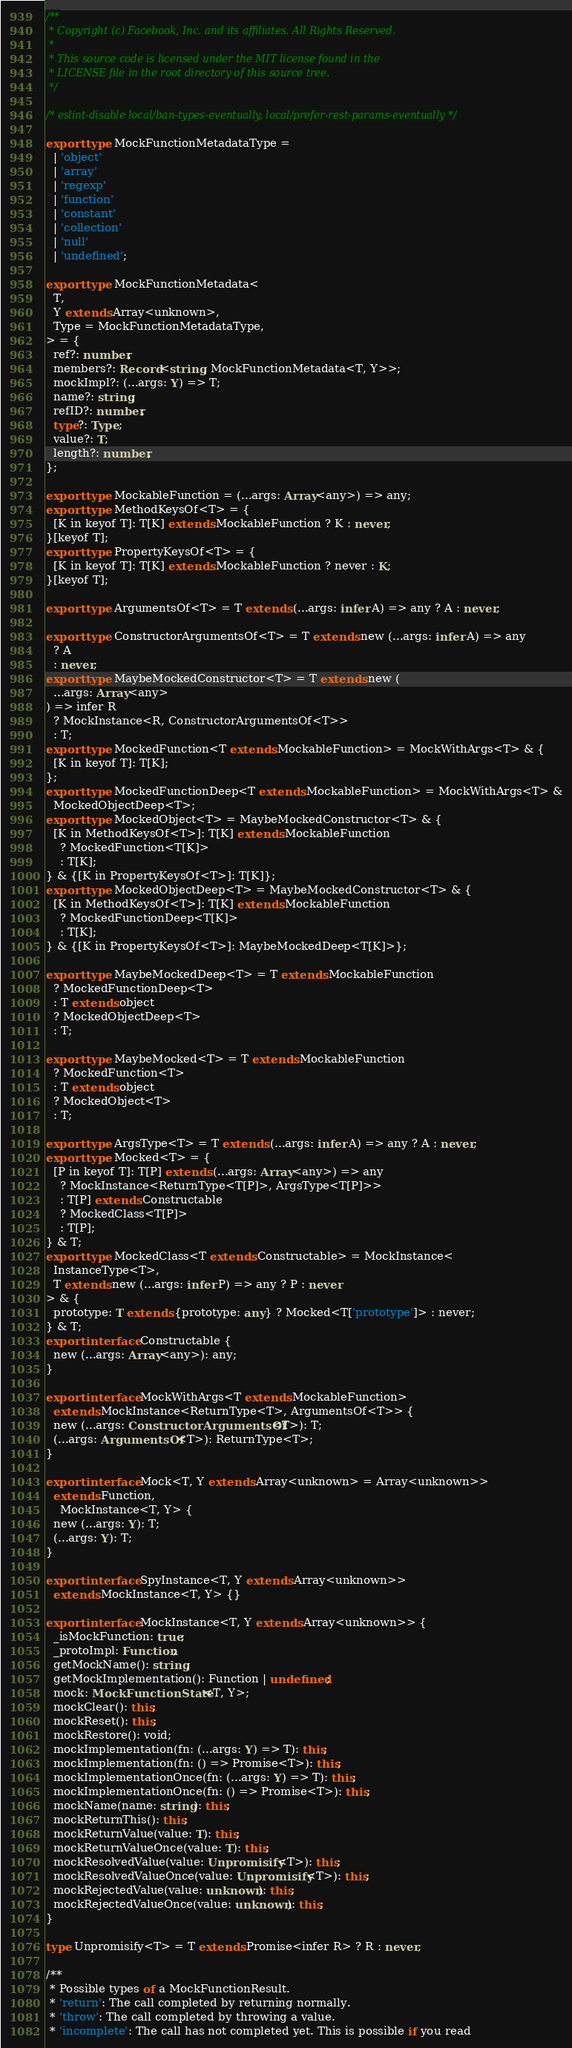Convert code to text. <code><loc_0><loc_0><loc_500><loc_500><_TypeScript_>/**
 * Copyright (c) Facebook, Inc. and its affiliates. All Rights Reserved.
 *
 * This source code is licensed under the MIT license found in the
 * LICENSE file in the root directory of this source tree.
 */

/* eslint-disable local/ban-types-eventually, local/prefer-rest-params-eventually */

export type MockFunctionMetadataType =
  | 'object'
  | 'array'
  | 'regexp'
  | 'function'
  | 'constant'
  | 'collection'
  | 'null'
  | 'undefined';

export type MockFunctionMetadata<
  T,
  Y extends Array<unknown>,
  Type = MockFunctionMetadataType,
> = {
  ref?: number;
  members?: Record<string, MockFunctionMetadata<T, Y>>;
  mockImpl?: (...args: Y) => T;
  name?: string;
  refID?: number;
  type?: Type;
  value?: T;
  length?: number;
};

export type MockableFunction = (...args: Array<any>) => any;
export type MethodKeysOf<T> = {
  [K in keyof T]: T[K] extends MockableFunction ? K : never;
}[keyof T];
export type PropertyKeysOf<T> = {
  [K in keyof T]: T[K] extends MockableFunction ? never : K;
}[keyof T];

export type ArgumentsOf<T> = T extends (...args: infer A) => any ? A : never;

export type ConstructorArgumentsOf<T> = T extends new (...args: infer A) => any
  ? A
  : never;
export type MaybeMockedConstructor<T> = T extends new (
  ...args: Array<any>
) => infer R
  ? MockInstance<R, ConstructorArgumentsOf<T>>
  : T;
export type MockedFunction<T extends MockableFunction> = MockWithArgs<T> & {
  [K in keyof T]: T[K];
};
export type MockedFunctionDeep<T extends MockableFunction> = MockWithArgs<T> &
  MockedObjectDeep<T>;
export type MockedObject<T> = MaybeMockedConstructor<T> & {
  [K in MethodKeysOf<T>]: T[K] extends MockableFunction
    ? MockedFunction<T[K]>
    : T[K];
} & {[K in PropertyKeysOf<T>]: T[K]};
export type MockedObjectDeep<T> = MaybeMockedConstructor<T> & {
  [K in MethodKeysOf<T>]: T[K] extends MockableFunction
    ? MockedFunctionDeep<T[K]>
    : T[K];
} & {[K in PropertyKeysOf<T>]: MaybeMockedDeep<T[K]>};

export type MaybeMockedDeep<T> = T extends MockableFunction
  ? MockedFunctionDeep<T>
  : T extends object
  ? MockedObjectDeep<T>
  : T;

export type MaybeMocked<T> = T extends MockableFunction
  ? MockedFunction<T>
  : T extends object
  ? MockedObject<T>
  : T;

export type ArgsType<T> = T extends (...args: infer A) => any ? A : never;
export type Mocked<T> = {
  [P in keyof T]: T[P] extends (...args: Array<any>) => any
    ? MockInstance<ReturnType<T[P]>, ArgsType<T[P]>>
    : T[P] extends Constructable
    ? MockedClass<T[P]>
    : T[P];
} & T;
export type MockedClass<T extends Constructable> = MockInstance<
  InstanceType<T>,
  T extends new (...args: infer P) => any ? P : never
> & {
  prototype: T extends {prototype: any} ? Mocked<T['prototype']> : never;
} & T;
export interface Constructable {
  new (...args: Array<any>): any;
}

export interface MockWithArgs<T extends MockableFunction>
  extends MockInstance<ReturnType<T>, ArgumentsOf<T>> {
  new (...args: ConstructorArgumentsOf<T>): T;
  (...args: ArgumentsOf<T>): ReturnType<T>;
}

export interface Mock<T, Y extends Array<unknown> = Array<unknown>>
  extends Function,
    MockInstance<T, Y> {
  new (...args: Y): T;
  (...args: Y): T;
}

export interface SpyInstance<T, Y extends Array<unknown>>
  extends MockInstance<T, Y> {}

export interface MockInstance<T, Y extends Array<unknown>> {
  _isMockFunction: true;
  _protoImpl: Function;
  getMockName(): string;
  getMockImplementation(): Function | undefined;
  mock: MockFunctionState<T, Y>;
  mockClear(): this;
  mockReset(): this;
  mockRestore(): void;
  mockImplementation(fn: (...args: Y) => T): this;
  mockImplementation(fn: () => Promise<T>): this;
  mockImplementationOnce(fn: (...args: Y) => T): this;
  mockImplementationOnce(fn: () => Promise<T>): this;
  mockName(name: string): this;
  mockReturnThis(): this;
  mockReturnValue(value: T): this;
  mockReturnValueOnce(value: T): this;
  mockResolvedValue(value: Unpromisify<T>): this;
  mockResolvedValueOnce(value: Unpromisify<T>): this;
  mockRejectedValue(value: unknown): this;
  mockRejectedValueOnce(value: unknown): this;
}

type Unpromisify<T> = T extends Promise<infer R> ? R : never;

/**
 * Possible types of a MockFunctionResult.
 * 'return': The call completed by returning normally.
 * 'throw': The call completed by throwing a value.
 * 'incomplete': The call has not completed yet. This is possible if you read</code> 